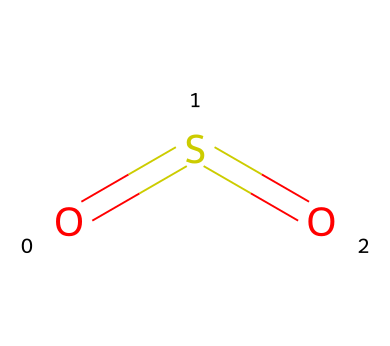What is the name of this compound? The structure represented by the SMILES code O=S=O denotes the compound sulfur dioxide, which is its common chemical name.
Answer: sulfur dioxide How many oxygen atoms are in the molecule? By examining the structure O=S=O, we see that there are two oxygen atoms connected to a sulfur atom, indicated by their presence in the formula.
Answer: 2 How many double bonds are present in sulfur dioxide? The chemical structure O=S=O shows a double bond between sulfur and each of the two oxygen atoms, which can be inferred from the representation of the bonds as "=".
Answer: 2 Is sulfur a hypervalent element in this compound? The arrangement of sulfur in sulfur dioxide shows that it has an expanded octet due to its ability to form more bonds than allowed by the octet rule, which confirms that sulfur acts as a hypervalent element here.
Answer: yes What is the oxidation state of sulfur in this compound? To determine the oxidation state, we can assign -2 to each oxygen (total -4) and balance it for the overall charge (0), deducing that sulfur must be +4 to achieve charge neutrality.
Answer: +4 What is the shape of the sulfur dioxide molecule? The molecular geometry of sulfur dioxide, based on its bent structure resulting from the arrangement of its bonding and lone pairs, follows the VSEPR theory, which leads to a bent shape due to repulsion between electrons.
Answer: bent 